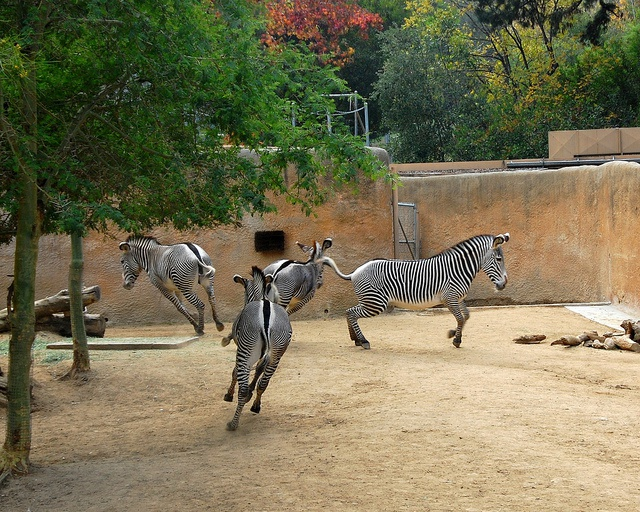Describe the objects in this image and their specific colors. I can see zebra in black, gray, darkgray, and lightgray tones, zebra in black, gray, and darkgray tones, zebra in black, gray, and darkgray tones, and zebra in black, gray, and darkgray tones in this image. 